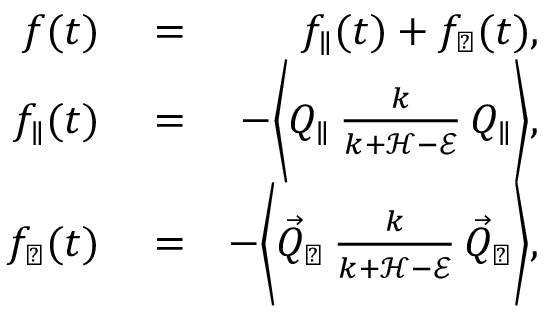<formula> <loc_0><loc_0><loc_500><loc_500>\begin{array} { r l r } { f ( t ) } & = } & { f _ { \| } ( t ) + f _ { \perp } ( t ) , } \\ { f _ { \| } ( t ) } & = } & { - \left \langle Q _ { \| } \, \frac { k } { k + \mathcal { H } - \mathcal { E } } \, Q _ { \| } \right \rangle , } \\ { f _ { \perp } ( t ) } & = } & { - \left \langle \vec { Q } _ { \perp } \, \frac { k } { k + \mathcal { H } - \mathcal { E } } \, \vec { Q } _ { \perp } \right \rangle , } \end{array}</formula> 